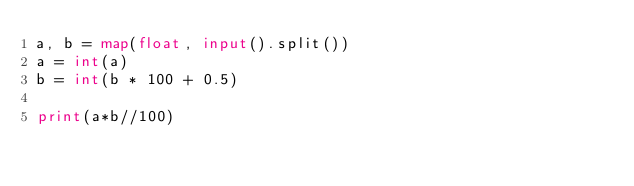<code> <loc_0><loc_0><loc_500><loc_500><_Python_>a, b = map(float, input().split())
a = int(a)
b = int(b * 100 + 0.5)

print(a*b//100)
</code> 